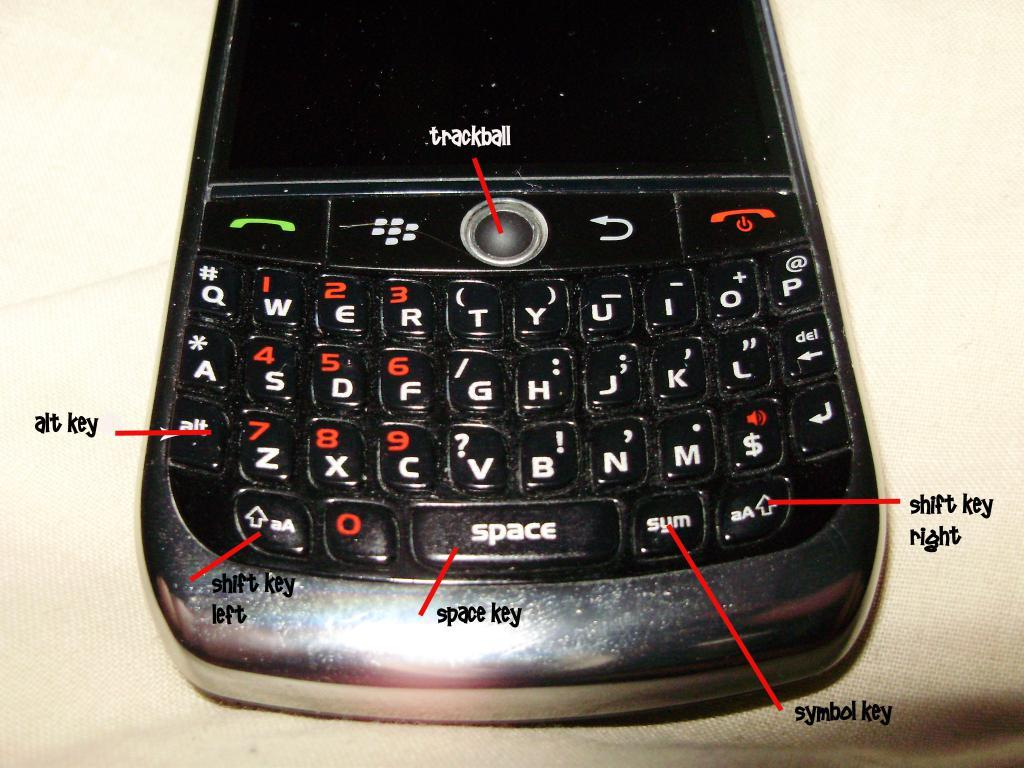<image>
Offer a succinct explanation of the picture presented. A cellphone with many labels on the keyboard such as trackball and space key. 